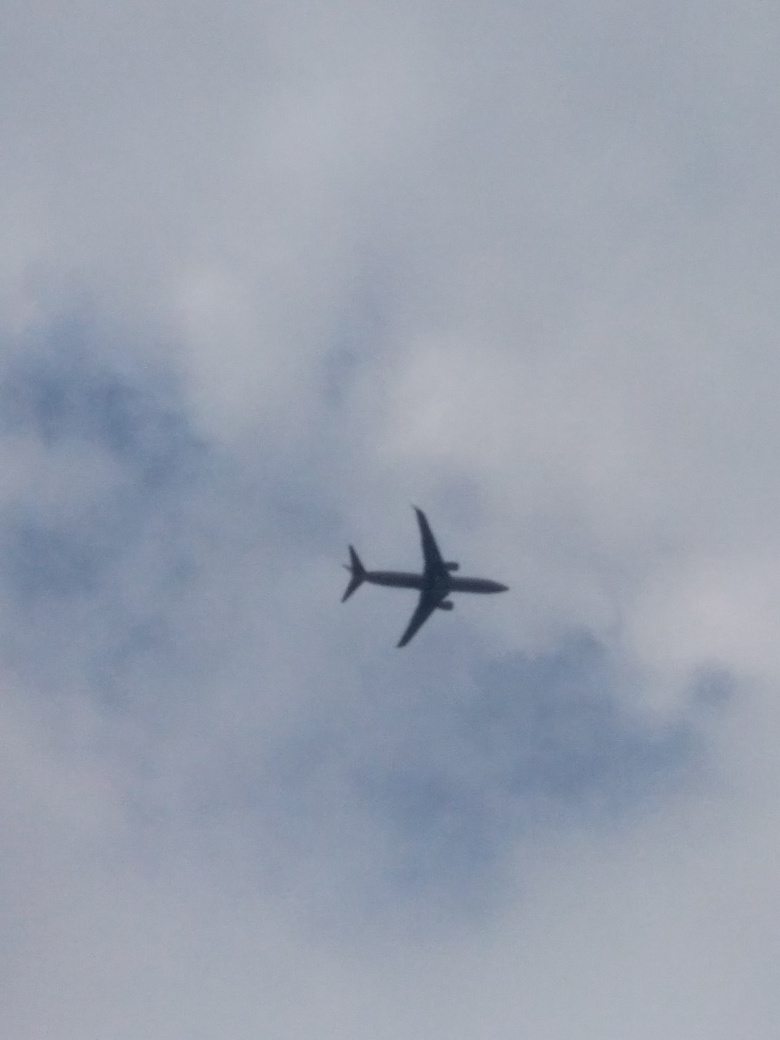Why is the scene dim in this image?
A. Bright lighting
B. Natural lighting
C. Poor lighting
Answer with the option's letter from the given choices directly.
 C. 